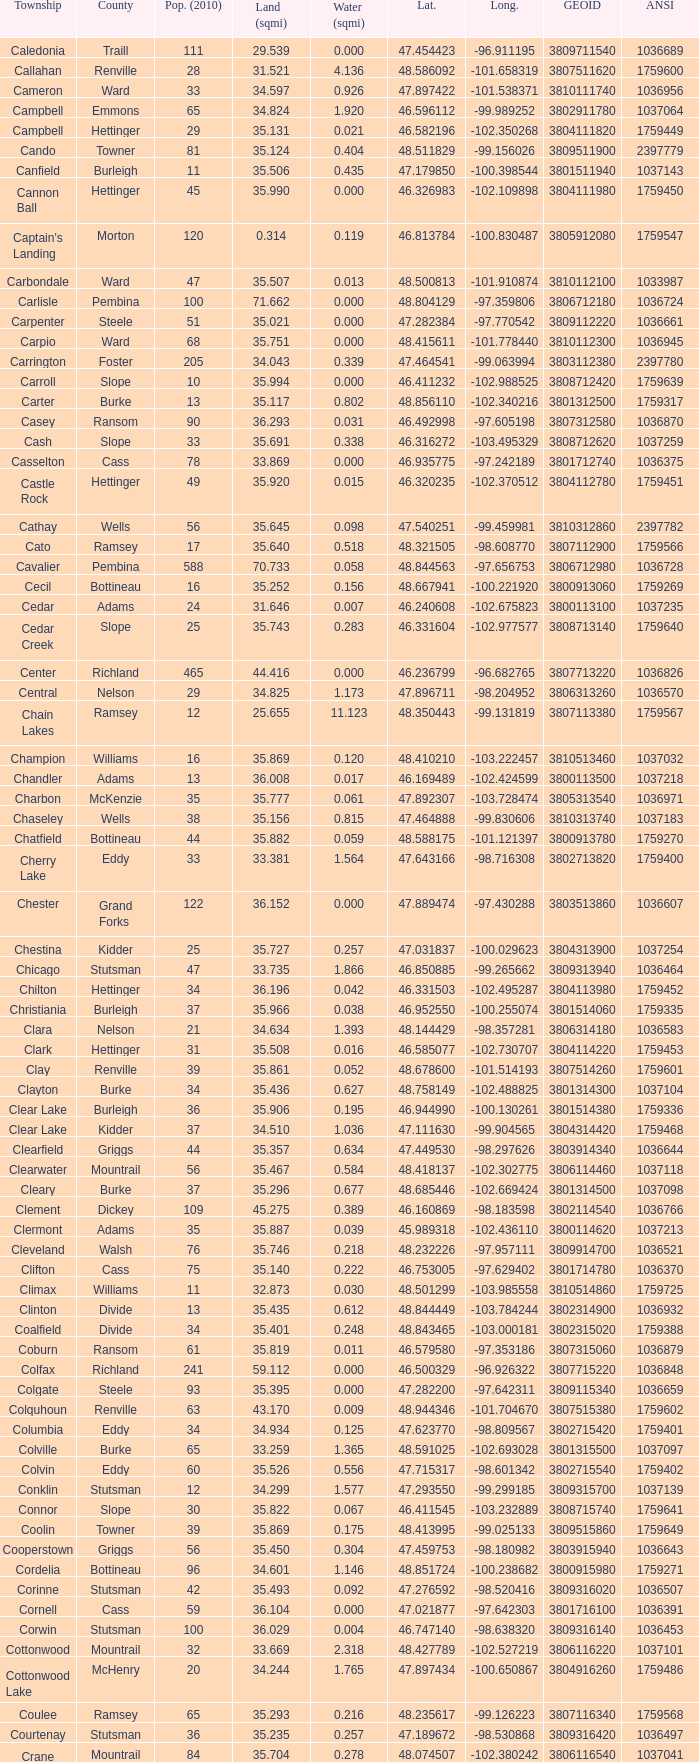What was the county with a latitude of 46.770977? Kidder. 